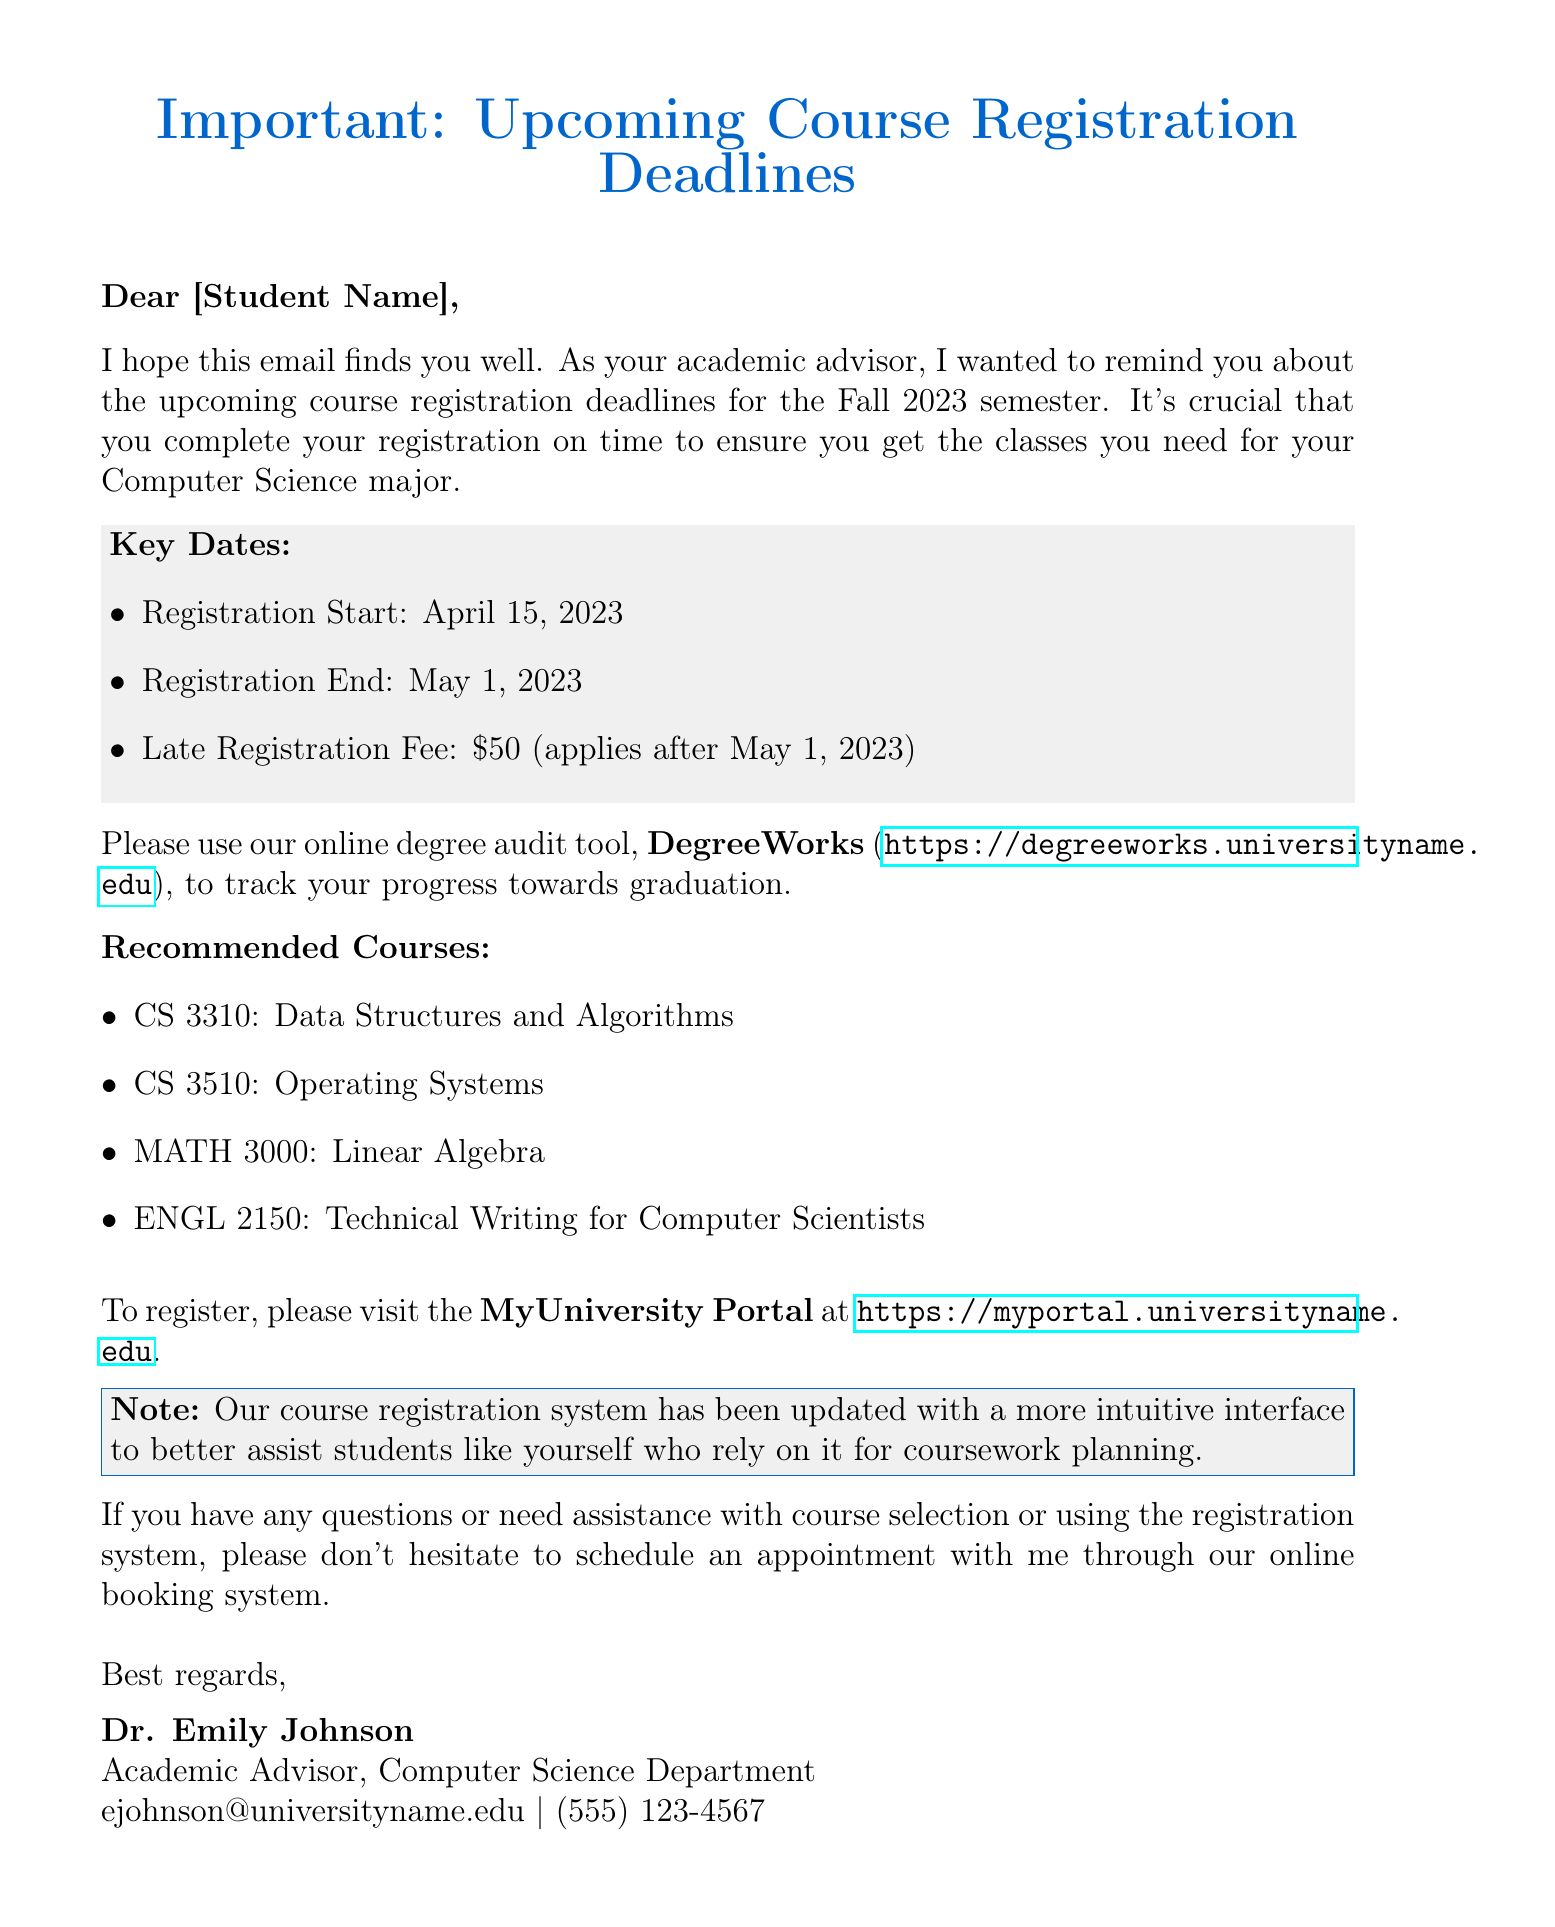what is the start date for registration? The start date for registration is explicitly provided in the document.
Answer: April 15, 2023 what is the late registration fee? The late registration fee is mentioned in the key dates section of the document.
Answer: $50 who is the sender of this email? The sender's name and title are mentioned at the end of the document.
Answer: Dr. Emily Johnson what tool should be used to track progress towards graduation? The document specifies the name of the tool for tracking graduation progress.
Answer: DegreeWorks how many recommended courses are listed? The number of recommended courses can be counted from the list provided in the document.
Answer: Four what is the registration end date? The end date for registration is specified in the document.
Answer: May 1, 2023 what is the purpose of this email? The purpose of the email is stated in the introductory paragraph.
Answer: Course registration deadlines what link should be used to register for courses? The link for the course registration system is provided in the document.
Answer: https://myportal.universityname.edu what major is the student advised for? The document specifies the student's major in the introductory paragraph.
Answer: Computer Science 